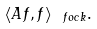<formula> <loc_0><loc_0><loc_500><loc_500>\langle A f , f \rangle _ { \ f o c k } .</formula> 